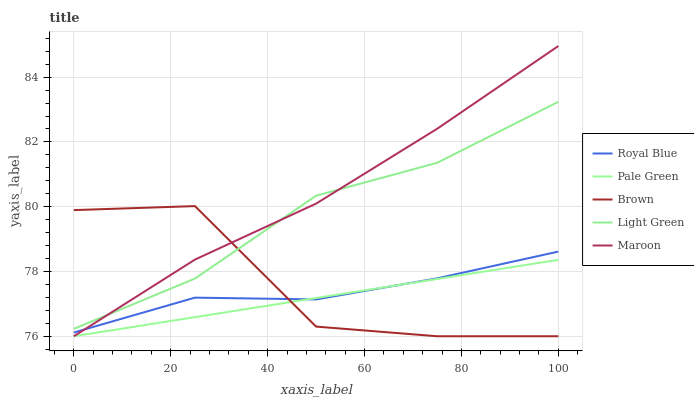Does Maroon have the minimum area under the curve?
Answer yes or no. No. Does Pale Green have the maximum area under the curve?
Answer yes or no. No. Is Maroon the smoothest?
Answer yes or no. No. Is Maroon the roughest?
Answer yes or no. No. Does Light Green have the lowest value?
Answer yes or no. No. Does Pale Green have the highest value?
Answer yes or no. No. Is Pale Green less than Light Green?
Answer yes or no. Yes. Is Light Green greater than Royal Blue?
Answer yes or no. Yes. Does Pale Green intersect Light Green?
Answer yes or no. No. 